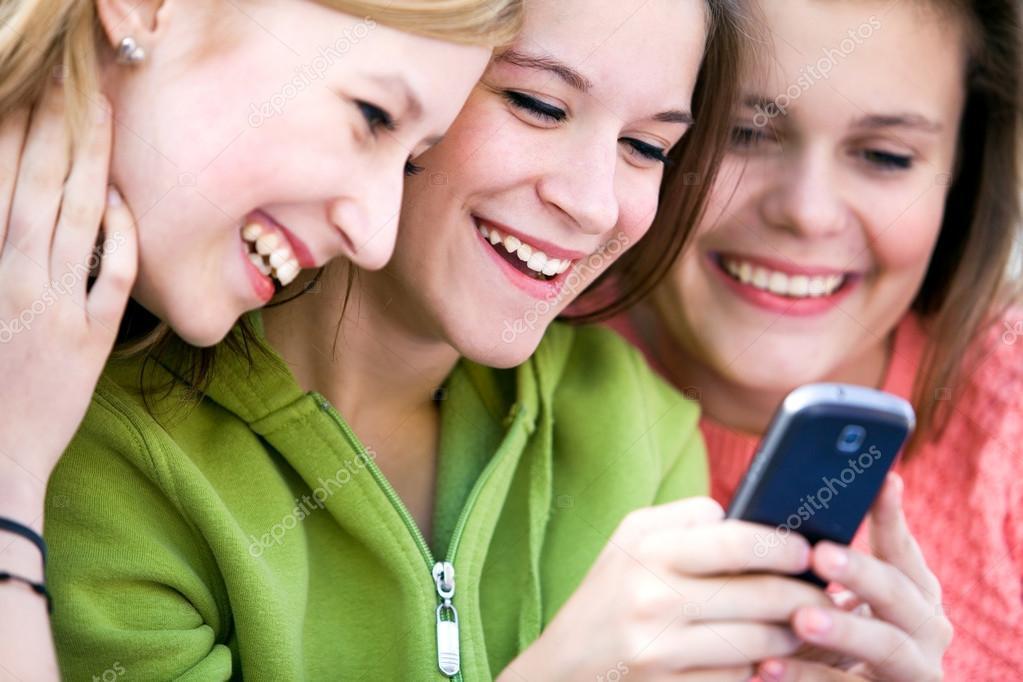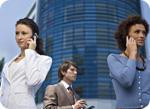The first image is the image on the left, the second image is the image on the right. Analyze the images presented: Is the assertion "The left image contains a row of exactly three girls, and each girl is looking at a phone, but not every girl is holding a phone." valid? Answer yes or no. Yes. The first image is the image on the left, the second image is the image on the right. Analyze the images presented: Is the assertion "The left and right image contains the same number of people on their phones." valid? Answer yes or no. Yes. 